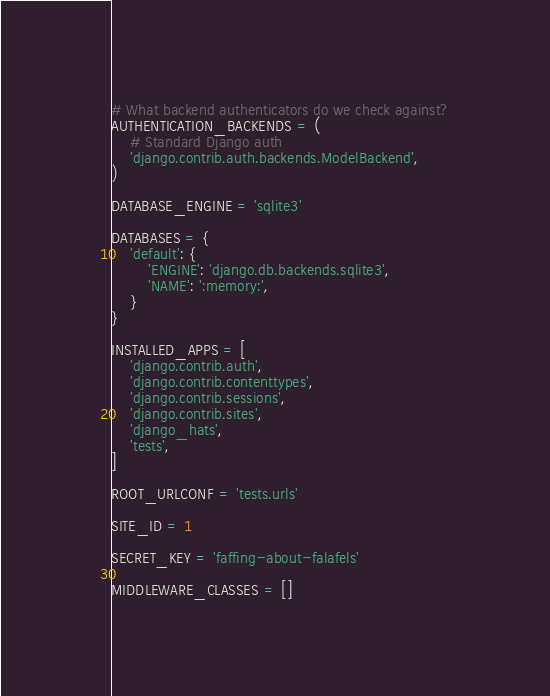<code> <loc_0><loc_0><loc_500><loc_500><_Python_># What backend authenticators do we check against?
AUTHENTICATION_BACKENDS = (
    # Standard Django auth
    'django.contrib.auth.backends.ModelBackend',
)

DATABASE_ENGINE = 'sqlite3'

DATABASES = {
    'default': {
        'ENGINE': 'django.db.backends.sqlite3',
        'NAME': ':memory:',
    }
}

INSTALLED_APPS = [
    'django.contrib.auth',
    'django.contrib.contenttypes',
    'django.contrib.sessions',
    'django.contrib.sites',
    'django_hats',
    'tests',
]

ROOT_URLCONF = 'tests.urls'

SITE_ID = 1

SECRET_KEY = 'faffing-about-falafels'

MIDDLEWARE_CLASSES = []
</code> 